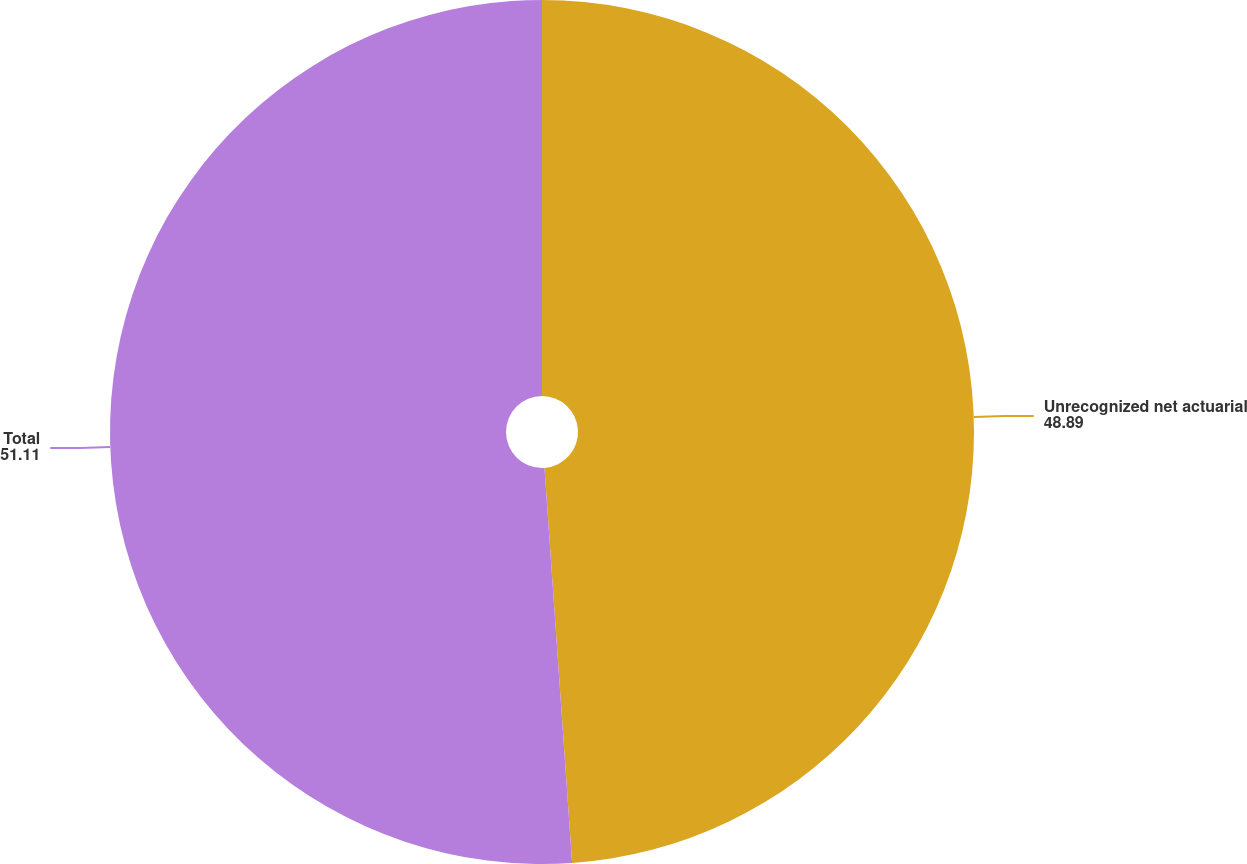Convert chart to OTSL. <chart><loc_0><loc_0><loc_500><loc_500><pie_chart><fcel>Unrecognized net actuarial<fcel>Total<nl><fcel>48.89%<fcel>51.11%<nl></chart> 